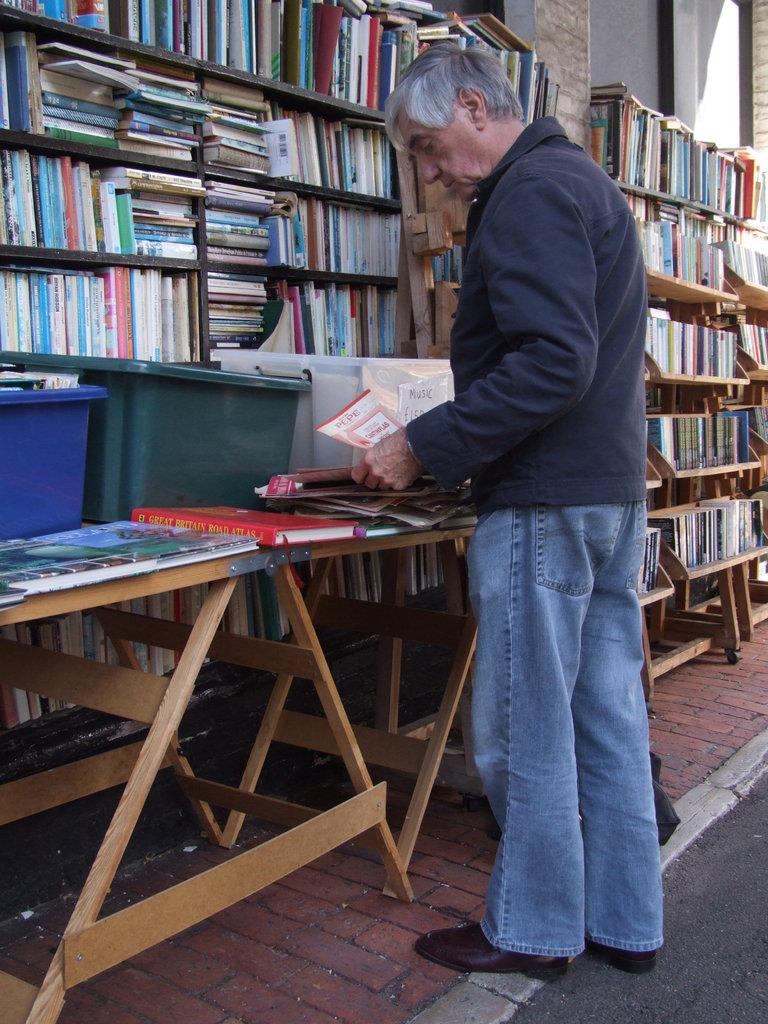What is the man in the image doing? The man is standing in the image and holding a book. Where is the man standing in the image? The man is standing at a table in the image. What can be seen in the background of the image? There are books in a cupboard in the background. How many tubs are visible in the image? There are three tubs in the image. What else is on the table besides the man? There are books on the table. What type of hearing aid is the man wearing in the image? The man is not wearing a hearing aid in the image; he is holding a book. What type of crook is the man using to hold the book in the image? The man is not using a crook to hold the book in the image; he is simply holding it with his hands. 